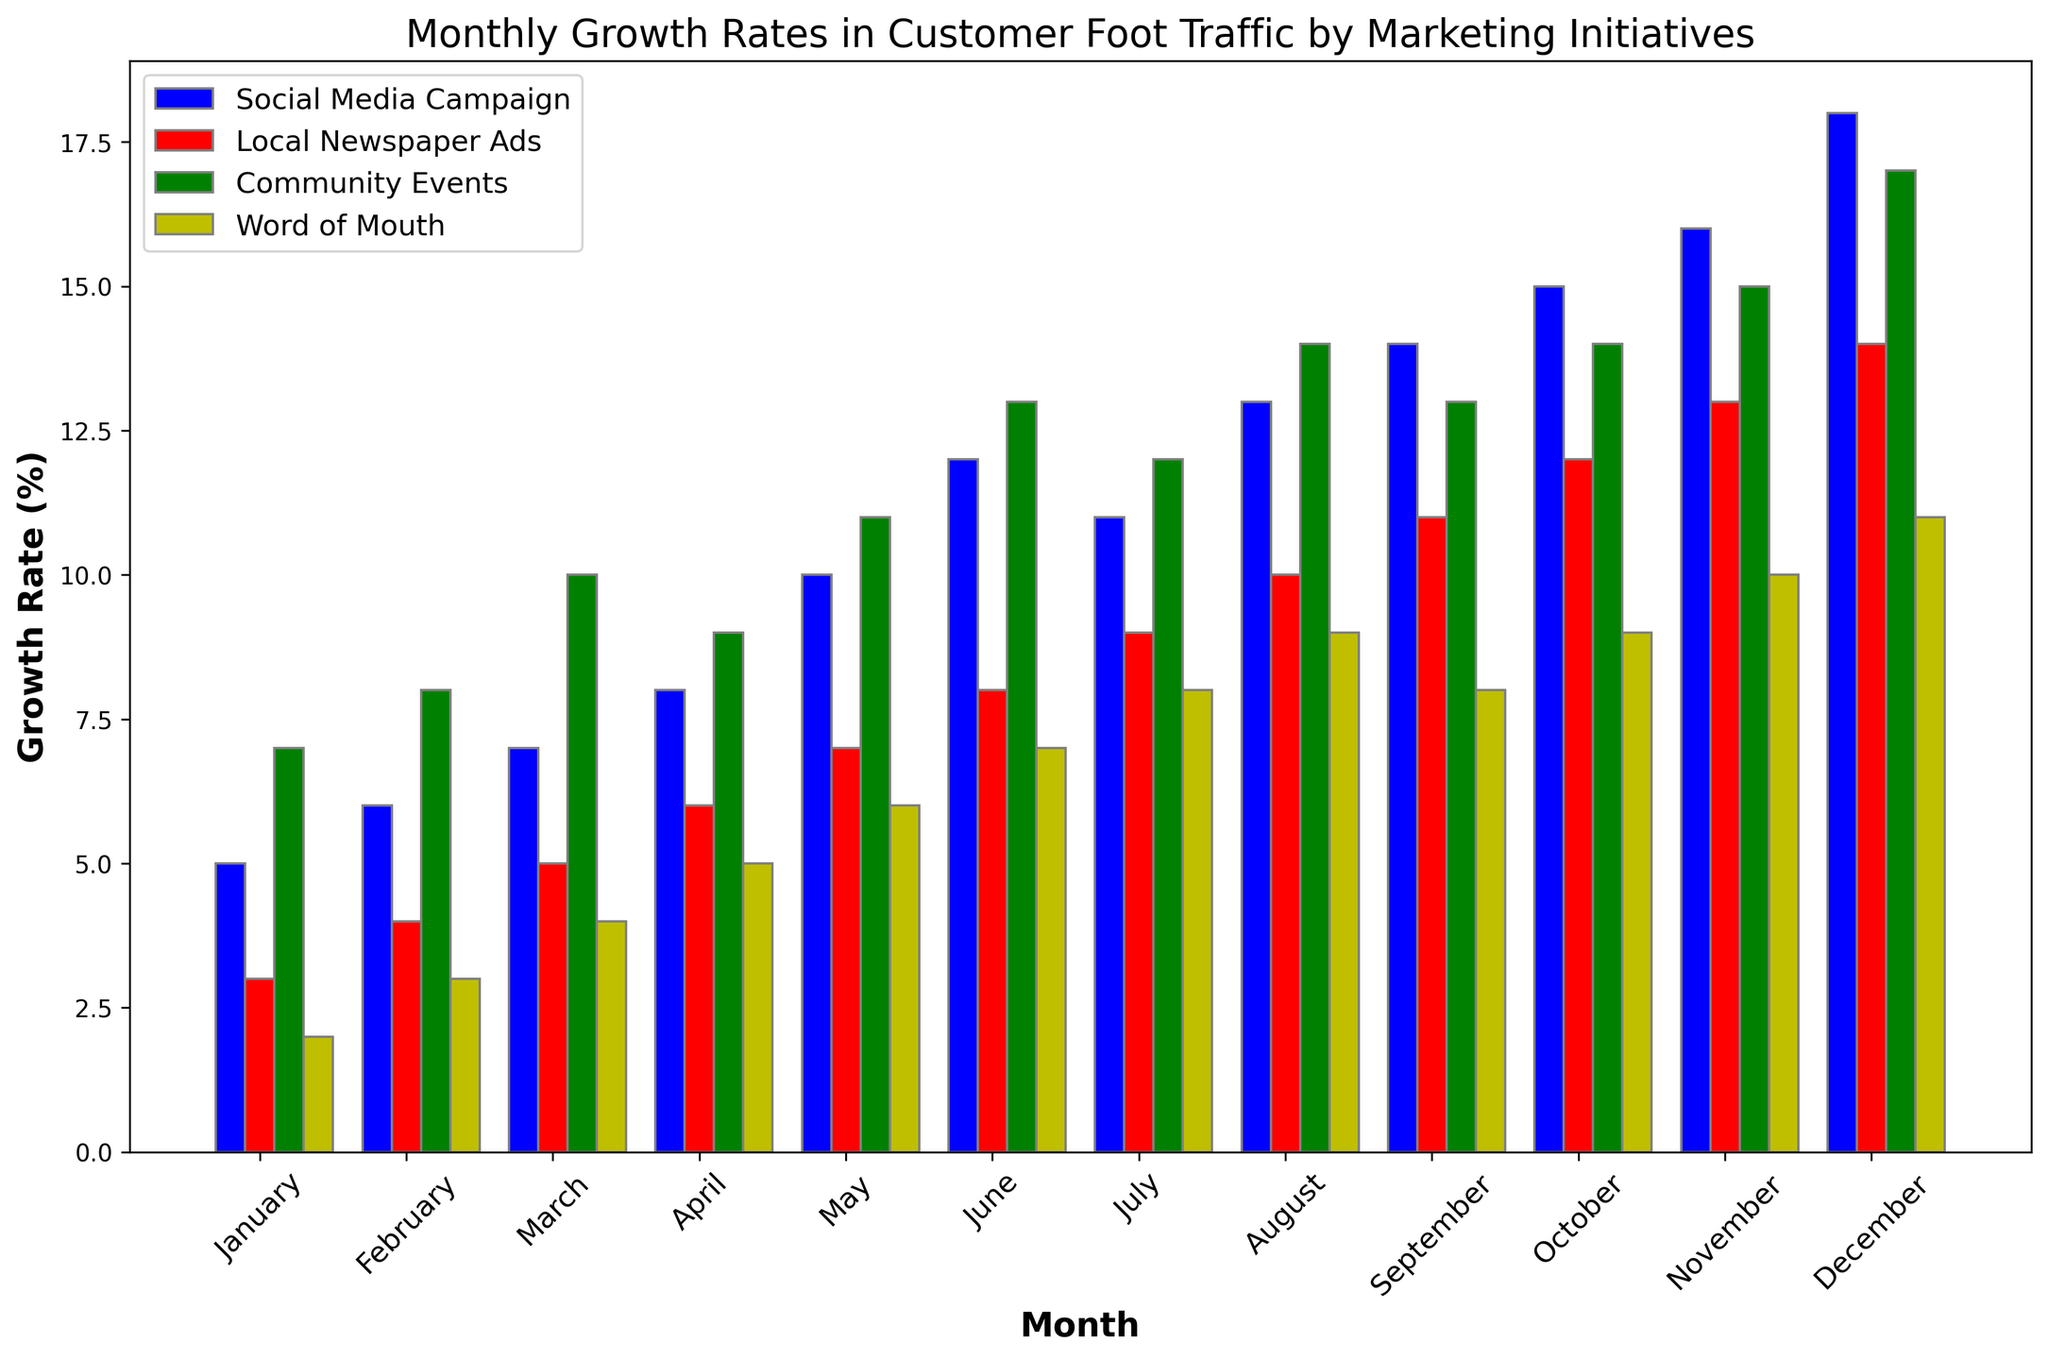What's the highest growth rate recorded for Social Media Campaign? Locate the highest bar for Social Media Campaign (blue bars) and find the corresponding value on the y-axis. The highest growth rate is observed in December.
Answer: 18% Which month had the lowest growth rate for Word of Mouth? Locate the lowest bar for Word of Mouth (yellow bars) and find the corresponding month. The lowest growth rate is observed in January.
Answer: January In which months did the Community Events (green bars) exceed Word of Mouth (yellow bars) in growth rate? Compare the height of the green bars (Community Events) with the yellow bars (Word of Mouth) for each month. Community Events exceeded Word of Mouth in January, February, March, April, May, June, July and November.
Answer: January, February, March, April, May, June, July, November What's the average growth rate for Local Newspaper Ads over the year? Sum the growth rates for Local Newspaper Ads (red bars) over the 12 months and divide by the number of months. (3+4+5+6+7+8+9+10+11+12+13+14)/12 = 8.
Answer: 8% Compare the growth rates for Social Media Campaign and Community Events in March; which one is higher and by how much? Locate the bars for March for both Social Media Campaign (blue) and Community Events (green). Subtract the height of the blue bar from the green bar. Community Events is 10 and Social Media Campaign is 7, so 10 - 7 = 3.
Answer: Community Events by 3% What was the cumulative growth rate for all initiatives in October? Sum the growth rates for all initiatives in October. 15 (Social Media Campaign) + 12 (Local Newspaper Ads) + 14 (Community Events) + 9 (Word of Mouth) = 50.
Answer: 50% Which marketing initiative had the most consistent growth across the months? Assess the variation in the height of the bars for each initiative over time. Local Newspaper Ads (red bars) show the least fluctuation compared to others.
Answer: Local Newspaper Ads How much did the growth rate for Social Media Campaign increase from January to December? Subtract the growth rate in January from that in December for Social Media Campaign. 18 (December) - 5 (January) = 13.
Answer: 13% Which month saw the highest collective growth from all marketing initiatives combined? Add the growth rates of all initiatives for each month and compare. The highest collective growth is observed in December (18+14+17+11 = 60).
Answer: December 